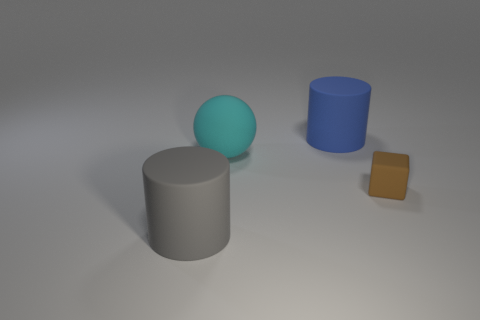Add 1 cyan balls. How many objects exist? 5 Subtract 0 purple cylinders. How many objects are left? 4 Subtract all blocks. How many objects are left? 3 Subtract all purple cubes. Subtract all gray spheres. How many cubes are left? 1 Subtract all cyan cubes. How many blue cylinders are left? 1 Subtract all large purple cubes. Subtract all large gray objects. How many objects are left? 3 Add 2 matte things. How many matte things are left? 6 Add 1 brown matte things. How many brown matte things exist? 2 Subtract all blue cylinders. How many cylinders are left? 1 